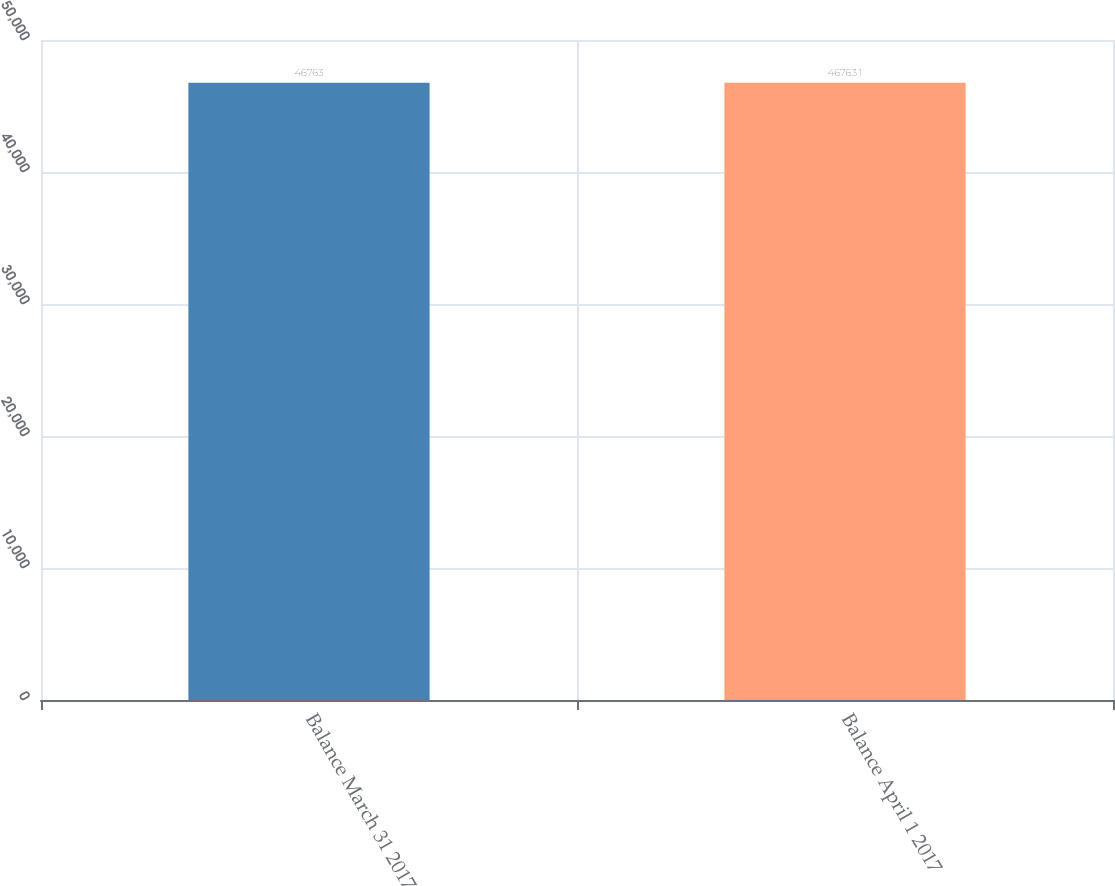Convert chart. <chart><loc_0><loc_0><loc_500><loc_500><bar_chart><fcel>Balance March 31 2017<fcel>Balance April 1 2017<nl><fcel>46763<fcel>46763.1<nl></chart> 